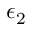Convert formula to latex. <formula><loc_0><loc_0><loc_500><loc_500>\epsilon _ { 2 }</formula> 